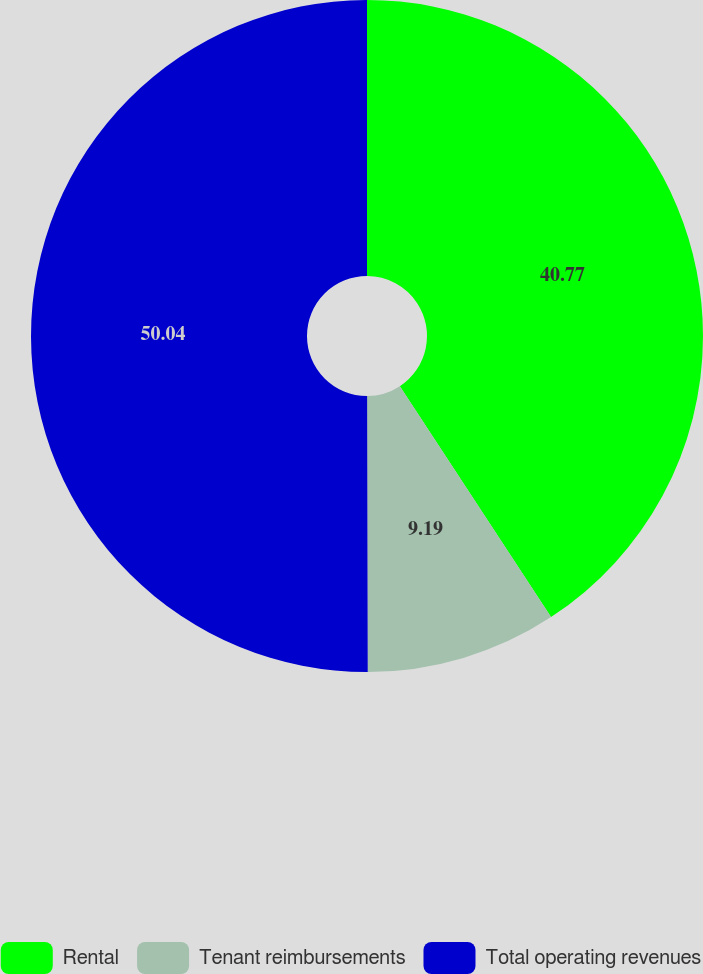<chart> <loc_0><loc_0><loc_500><loc_500><pie_chart><fcel>Rental<fcel>Tenant reimbursements<fcel>Total operating revenues<nl><fcel>40.77%<fcel>9.19%<fcel>50.03%<nl></chart> 